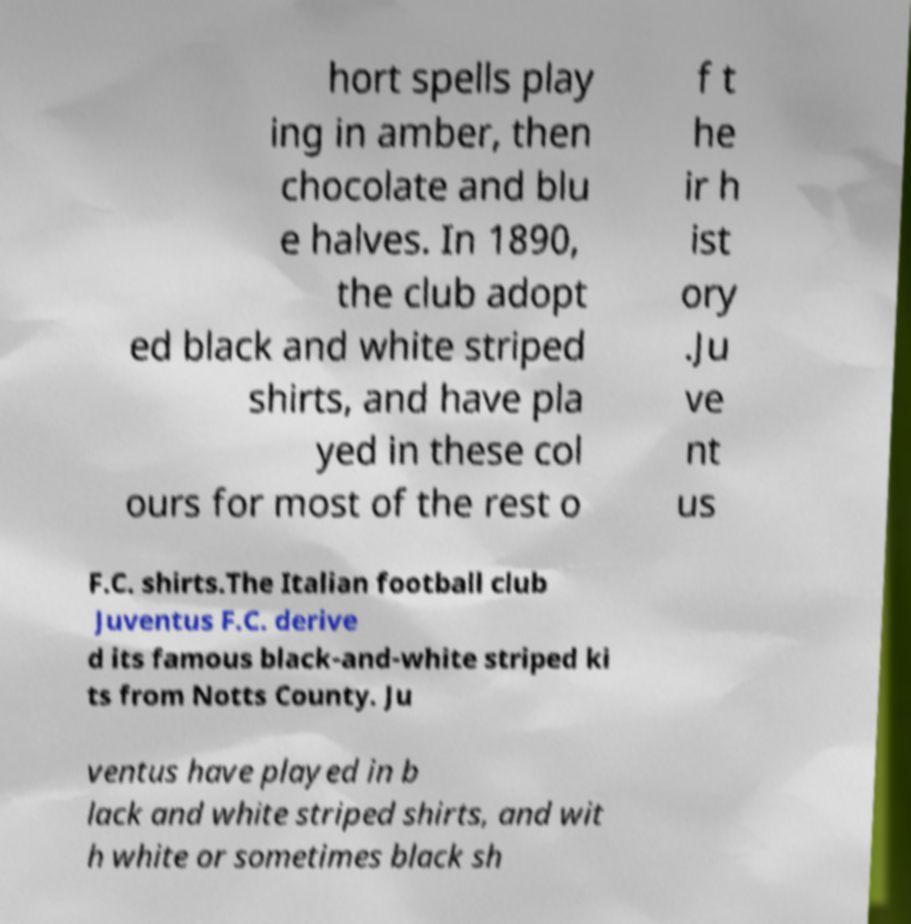Can you read and provide the text displayed in the image?This photo seems to have some interesting text. Can you extract and type it out for me? hort spells play ing in amber, then chocolate and blu e halves. In 1890, the club adopt ed black and white striped shirts, and have pla yed in these col ours for most of the rest o f t he ir h ist ory .Ju ve nt us F.C. shirts.The Italian football club Juventus F.C. derive d its famous black-and-white striped ki ts from Notts County. Ju ventus have played in b lack and white striped shirts, and wit h white or sometimes black sh 